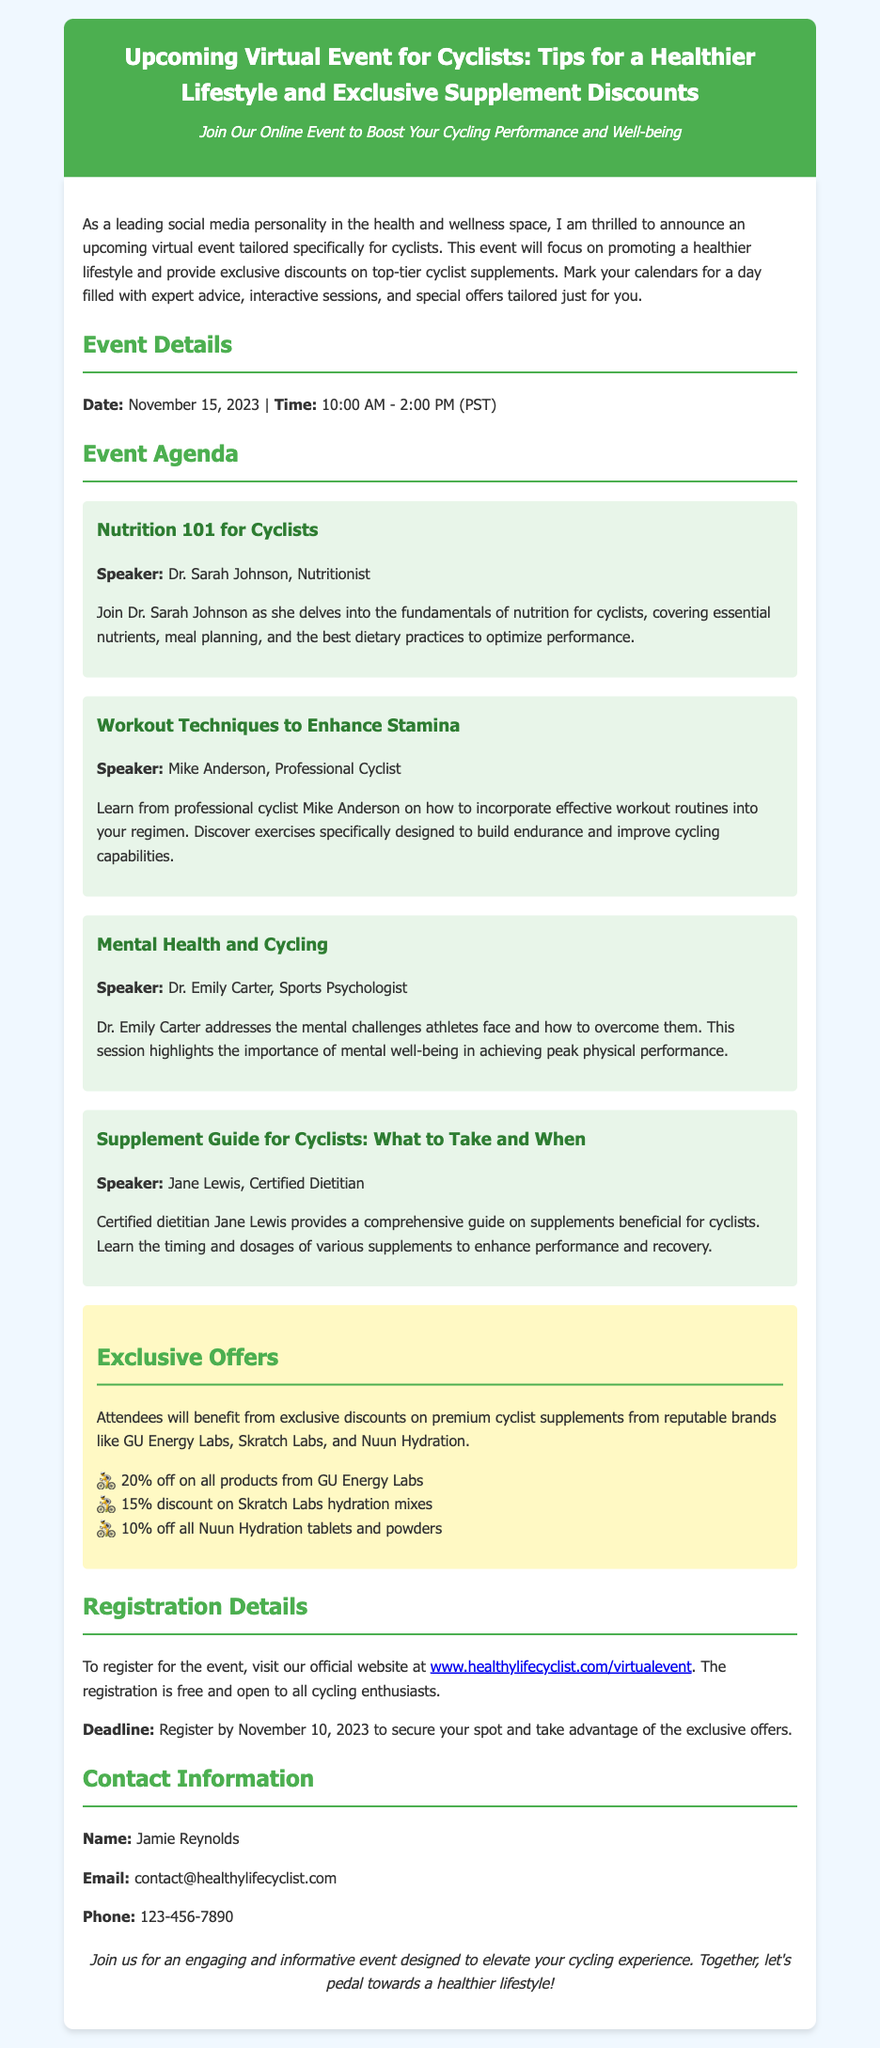What is the date of the event? The date of the event is provided in the event details section of the document.
Answer: November 15, 2023 Who is the speaker for the Nutrition 101 session? The session includes the name of the speaker as part of the agenda section.
Answer: Dr. Sarah Johnson What time does the event start? The start time of the event is specified in the event details section.
Answer: 10:00 AM What discount will attendees receive on GU Energy Labs products? This information is found in the exclusive offers section of the document.
Answer: 20% off What topic will Dr. Emily Carter address? The document indicates the focus of Dr. Emily Carter's session in the agenda section.
Answer: Mental Health and Cycling What is the registration deadline for the event? The registration deadline is explicitly stated in the registration details section.
Answer: November 10, 2023 What is the format of the event? The format of the event is outlined in the introductory paragraph and event description.
Answer: Virtual event Who should be contacted for more information? The contact section provides the name of the person for further inquiries.
Answer: Jamie Reynolds 